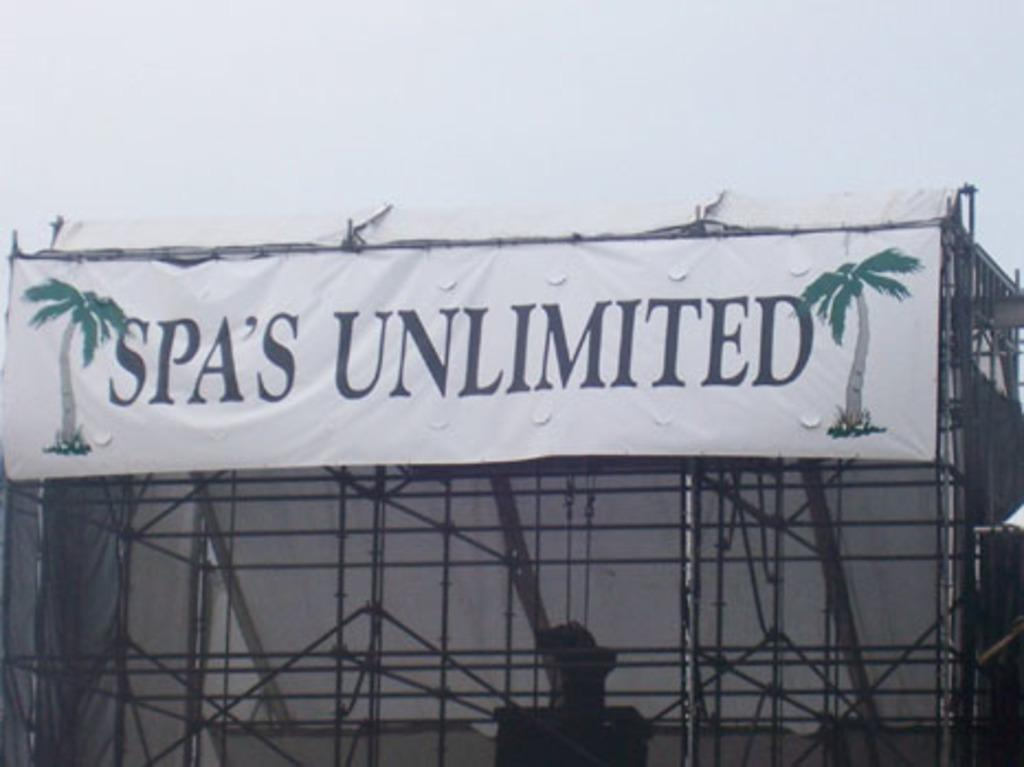<image>
Give a short and clear explanation of the subsequent image. A banner on a structure advertising a spa 